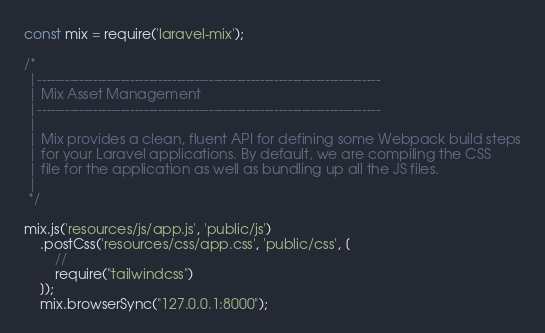<code> <loc_0><loc_0><loc_500><loc_500><_JavaScript_>const mix = require('laravel-mix');

/*
 |--------------------------------------------------------------------------
 | Mix Asset Management
 |--------------------------------------------------------------------------
 |
 | Mix provides a clean, fluent API for defining some Webpack build steps
 | for your Laravel applications. By default, we are compiling the CSS
 | file for the application as well as bundling up all the JS files.
 |
 */

mix.js('resources/js/app.js', 'public/js')
    .postCss('resources/css/app.css', 'public/css', [
        //
        require("tailwindcss")
    ]);
    mix.browserSync("127.0.0.1:8000");
</code> 